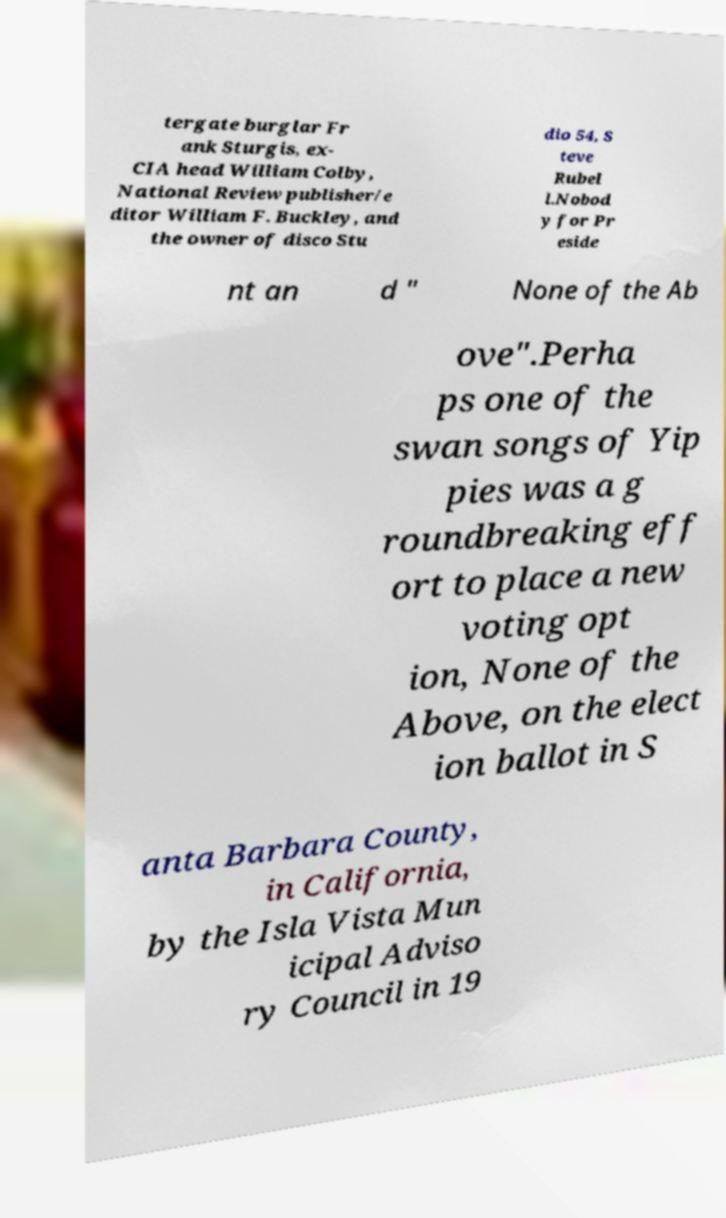Please identify and transcribe the text found in this image. tergate burglar Fr ank Sturgis, ex- CIA head William Colby, National Review publisher/e ditor William F. Buckley, and the owner of disco Stu dio 54, S teve Rubel l.Nobod y for Pr eside nt an d " None of the Ab ove".Perha ps one of the swan songs of Yip pies was a g roundbreaking eff ort to place a new voting opt ion, None of the Above, on the elect ion ballot in S anta Barbara County, in California, by the Isla Vista Mun icipal Adviso ry Council in 19 